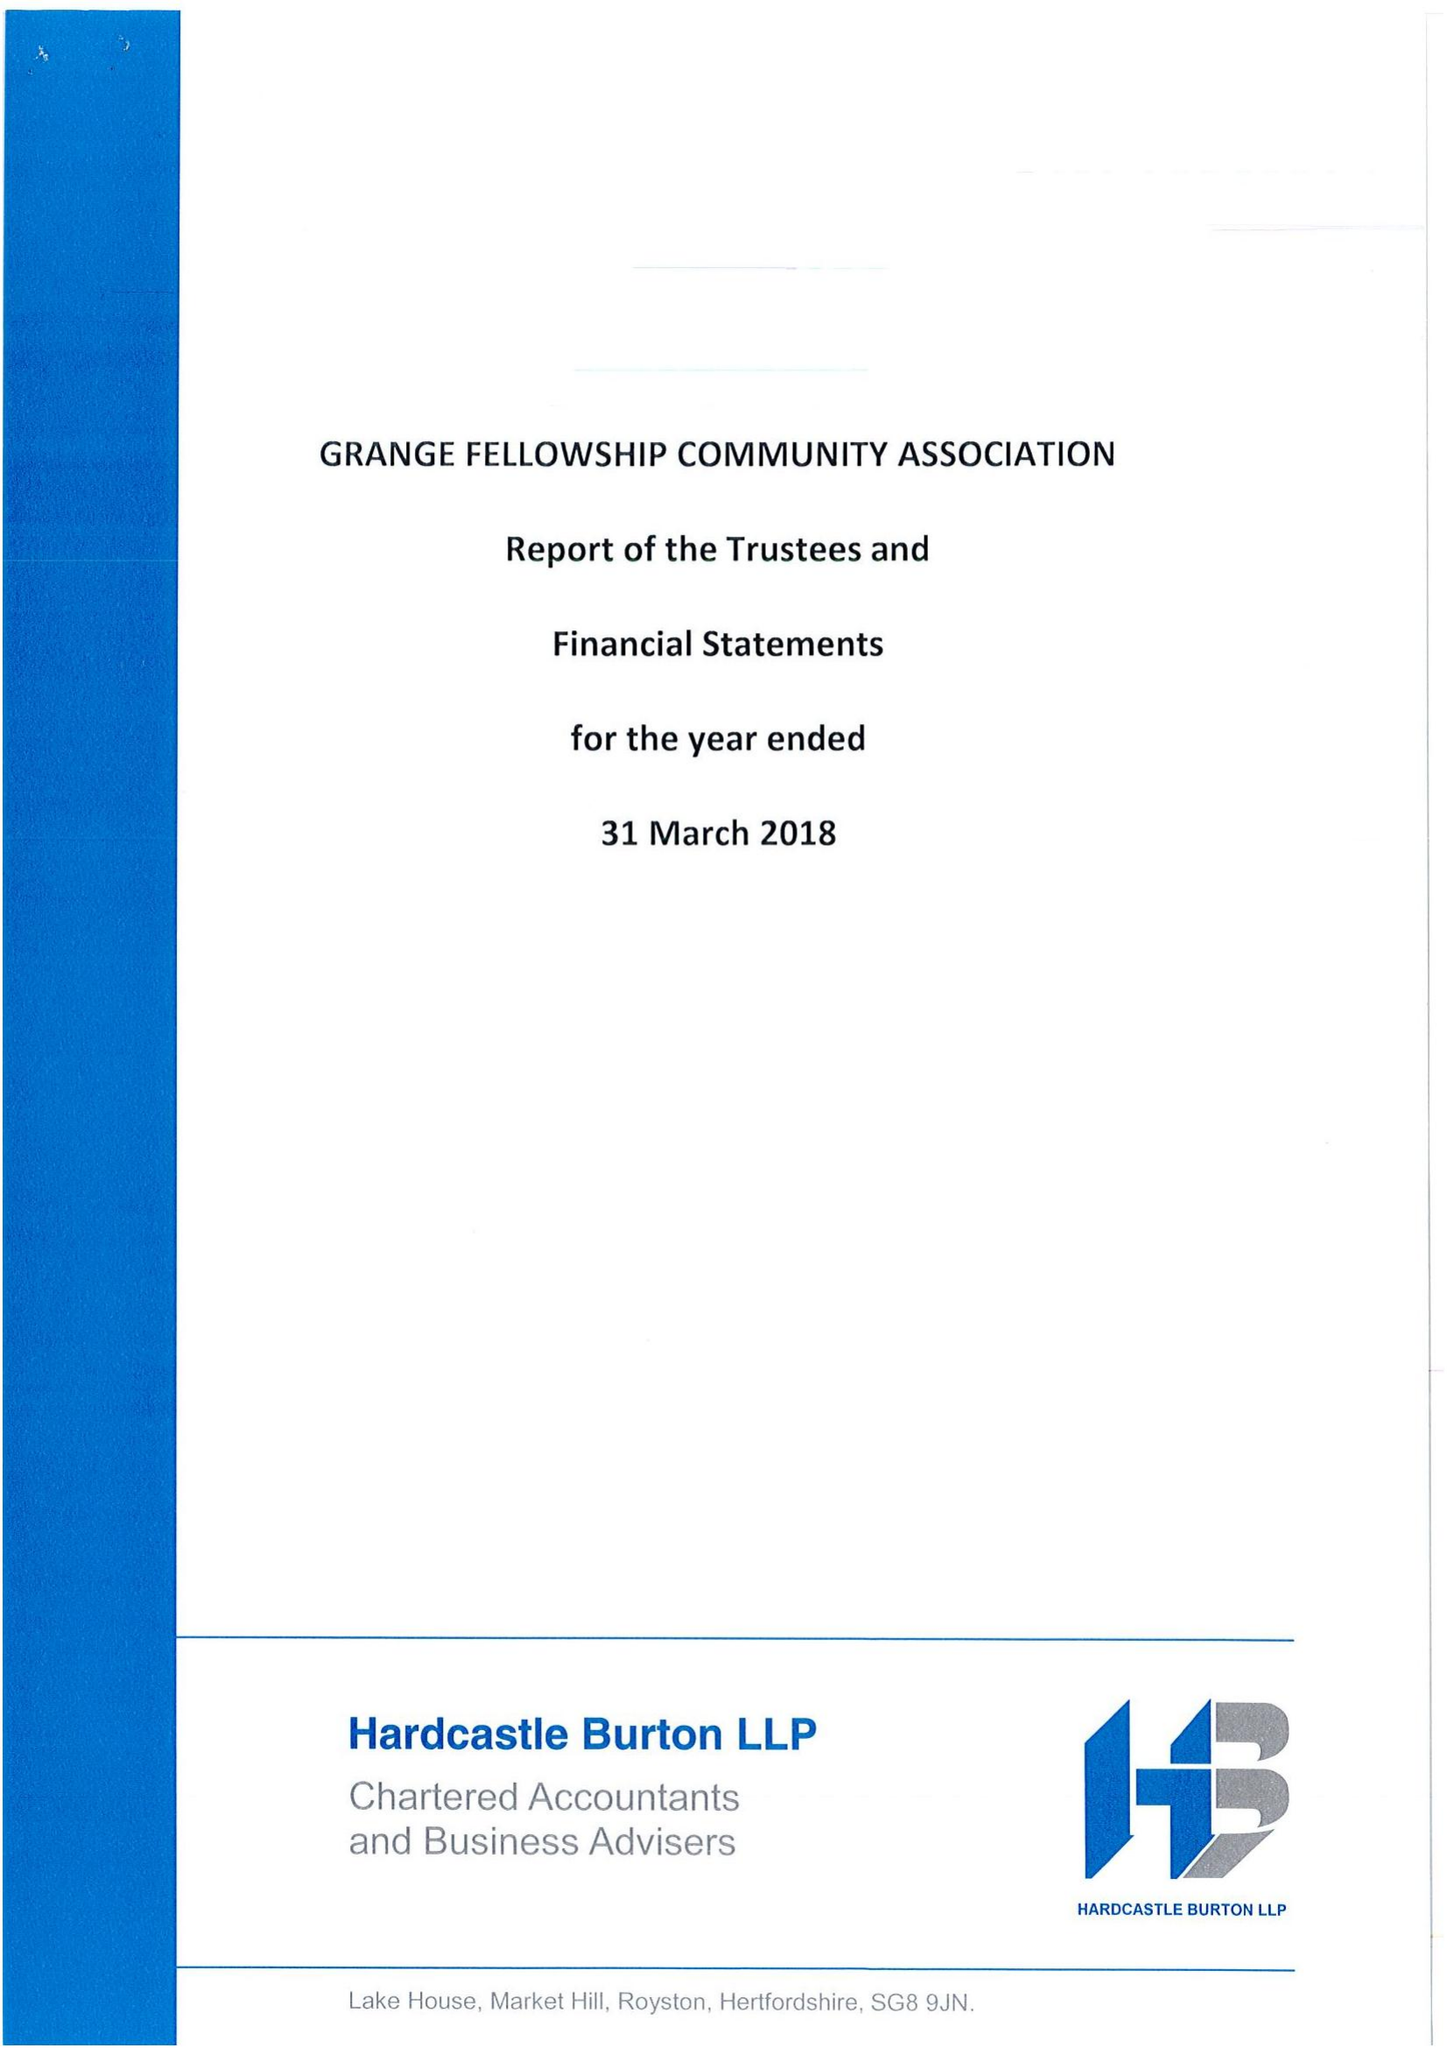What is the value for the income_annually_in_british_pounds?
Answer the question using a single word or phrase. 460163.00 